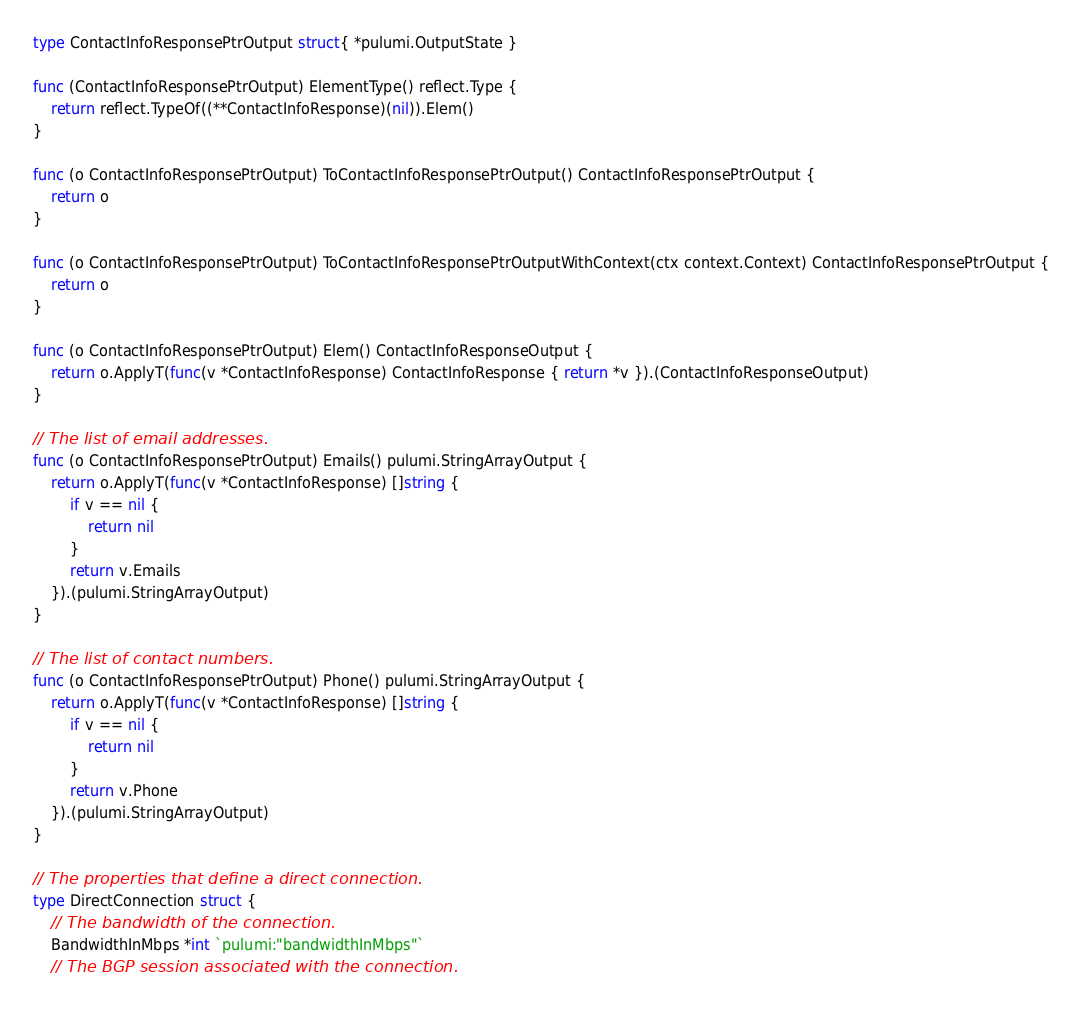Convert code to text. <code><loc_0><loc_0><loc_500><loc_500><_Go_>
type ContactInfoResponsePtrOutput struct{ *pulumi.OutputState }

func (ContactInfoResponsePtrOutput) ElementType() reflect.Type {
	return reflect.TypeOf((**ContactInfoResponse)(nil)).Elem()
}

func (o ContactInfoResponsePtrOutput) ToContactInfoResponsePtrOutput() ContactInfoResponsePtrOutput {
	return o
}

func (o ContactInfoResponsePtrOutput) ToContactInfoResponsePtrOutputWithContext(ctx context.Context) ContactInfoResponsePtrOutput {
	return o
}

func (o ContactInfoResponsePtrOutput) Elem() ContactInfoResponseOutput {
	return o.ApplyT(func(v *ContactInfoResponse) ContactInfoResponse { return *v }).(ContactInfoResponseOutput)
}

// The list of email addresses.
func (o ContactInfoResponsePtrOutput) Emails() pulumi.StringArrayOutput {
	return o.ApplyT(func(v *ContactInfoResponse) []string {
		if v == nil {
			return nil
		}
		return v.Emails
	}).(pulumi.StringArrayOutput)
}

// The list of contact numbers.
func (o ContactInfoResponsePtrOutput) Phone() pulumi.StringArrayOutput {
	return o.ApplyT(func(v *ContactInfoResponse) []string {
		if v == nil {
			return nil
		}
		return v.Phone
	}).(pulumi.StringArrayOutput)
}

// The properties that define a direct connection.
type DirectConnection struct {
	// The bandwidth of the connection.
	BandwidthInMbps *int `pulumi:"bandwidthInMbps"`
	// The BGP session associated with the connection.</code> 